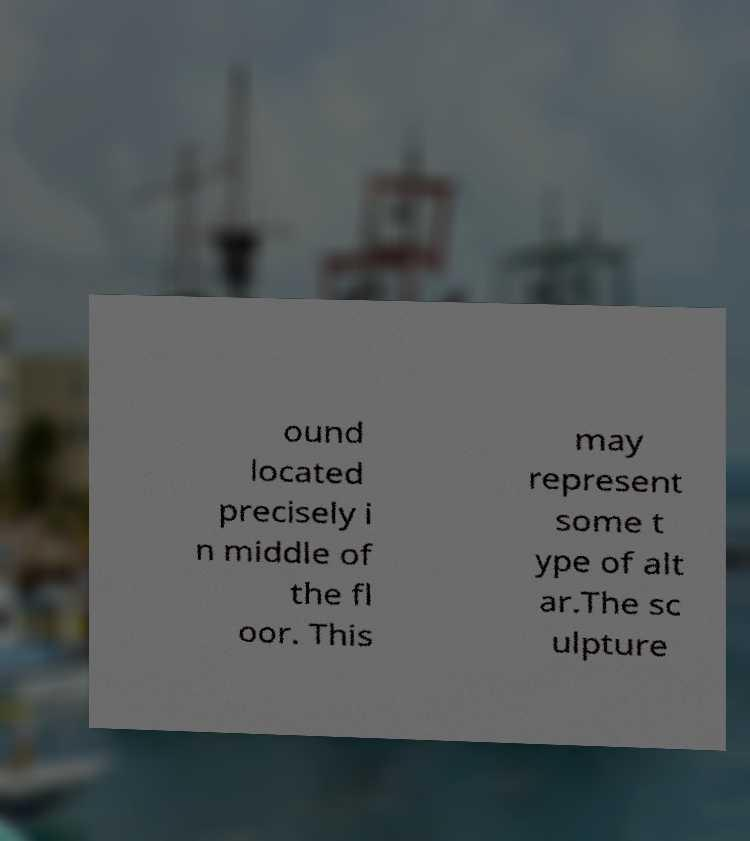I need the written content from this picture converted into text. Can you do that? ound located precisely i n middle of the fl oor. This may represent some t ype of alt ar.The sc ulpture 